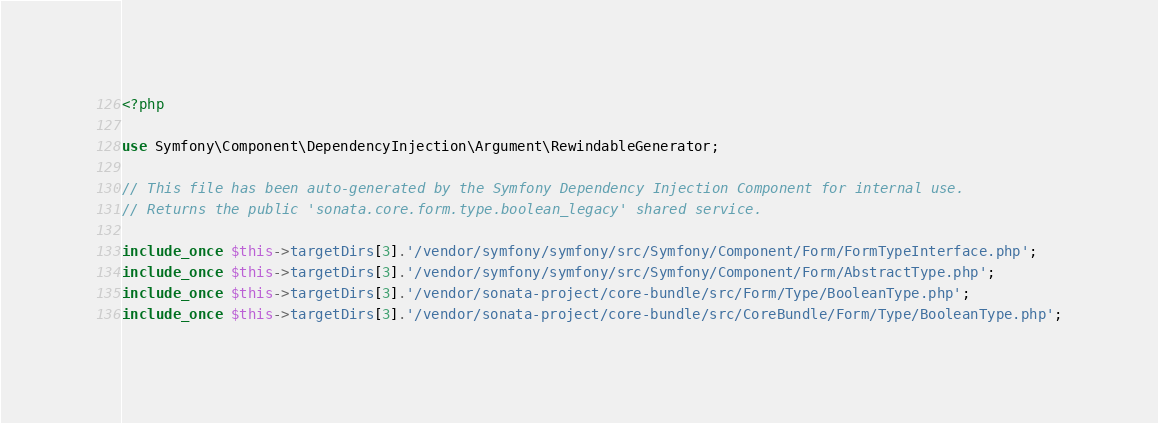Convert code to text. <code><loc_0><loc_0><loc_500><loc_500><_PHP_><?php

use Symfony\Component\DependencyInjection\Argument\RewindableGenerator;

// This file has been auto-generated by the Symfony Dependency Injection Component for internal use.
// Returns the public 'sonata.core.form.type.boolean_legacy' shared service.

include_once $this->targetDirs[3].'/vendor/symfony/symfony/src/Symfony/Component/Form/FormTypeInterface.php';
include_once $this->targetDirs[3].'/vendor/symfony/symfony/src/Symfony/Component/Form/AbstractType.php';
include_once $this->targetDirs[3].'/vendor/sonata-project/core-bundle/src/Form/Type/BooleanType.php';
include_once $this->targetDirs[3].'/vendor/sonata-project/core-bundle/src/CoreBundle/Form/Type/BooleanType.php';
</code> 